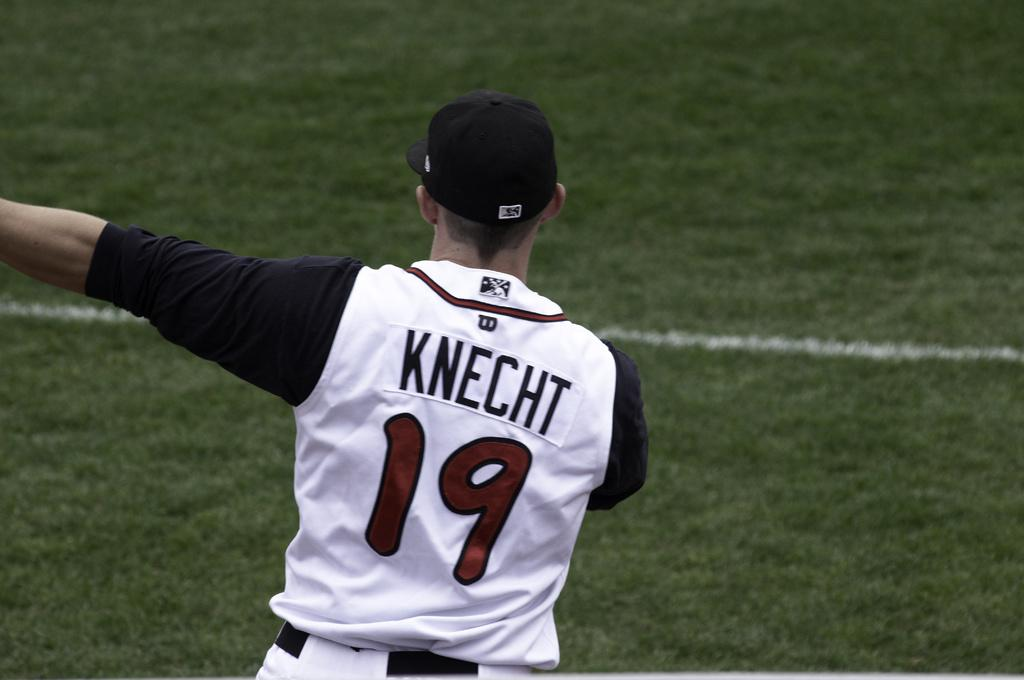<image>
Present a compact description of the photo's key features. a baseball player with the last name knecht 